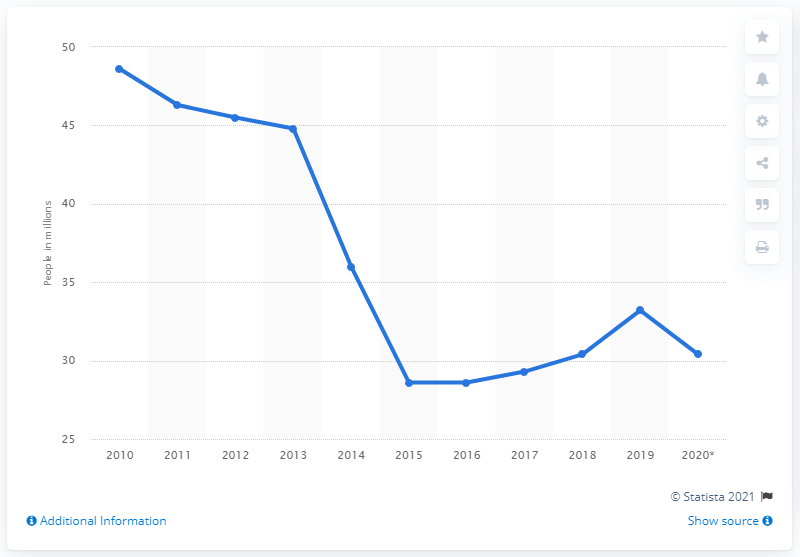Specify some key components in this picture. In the first half of 2020, an estimated 30.4 million people in the United States lacked health insurance coverage. The number of Americans without health insurance began to increase in 2015. 